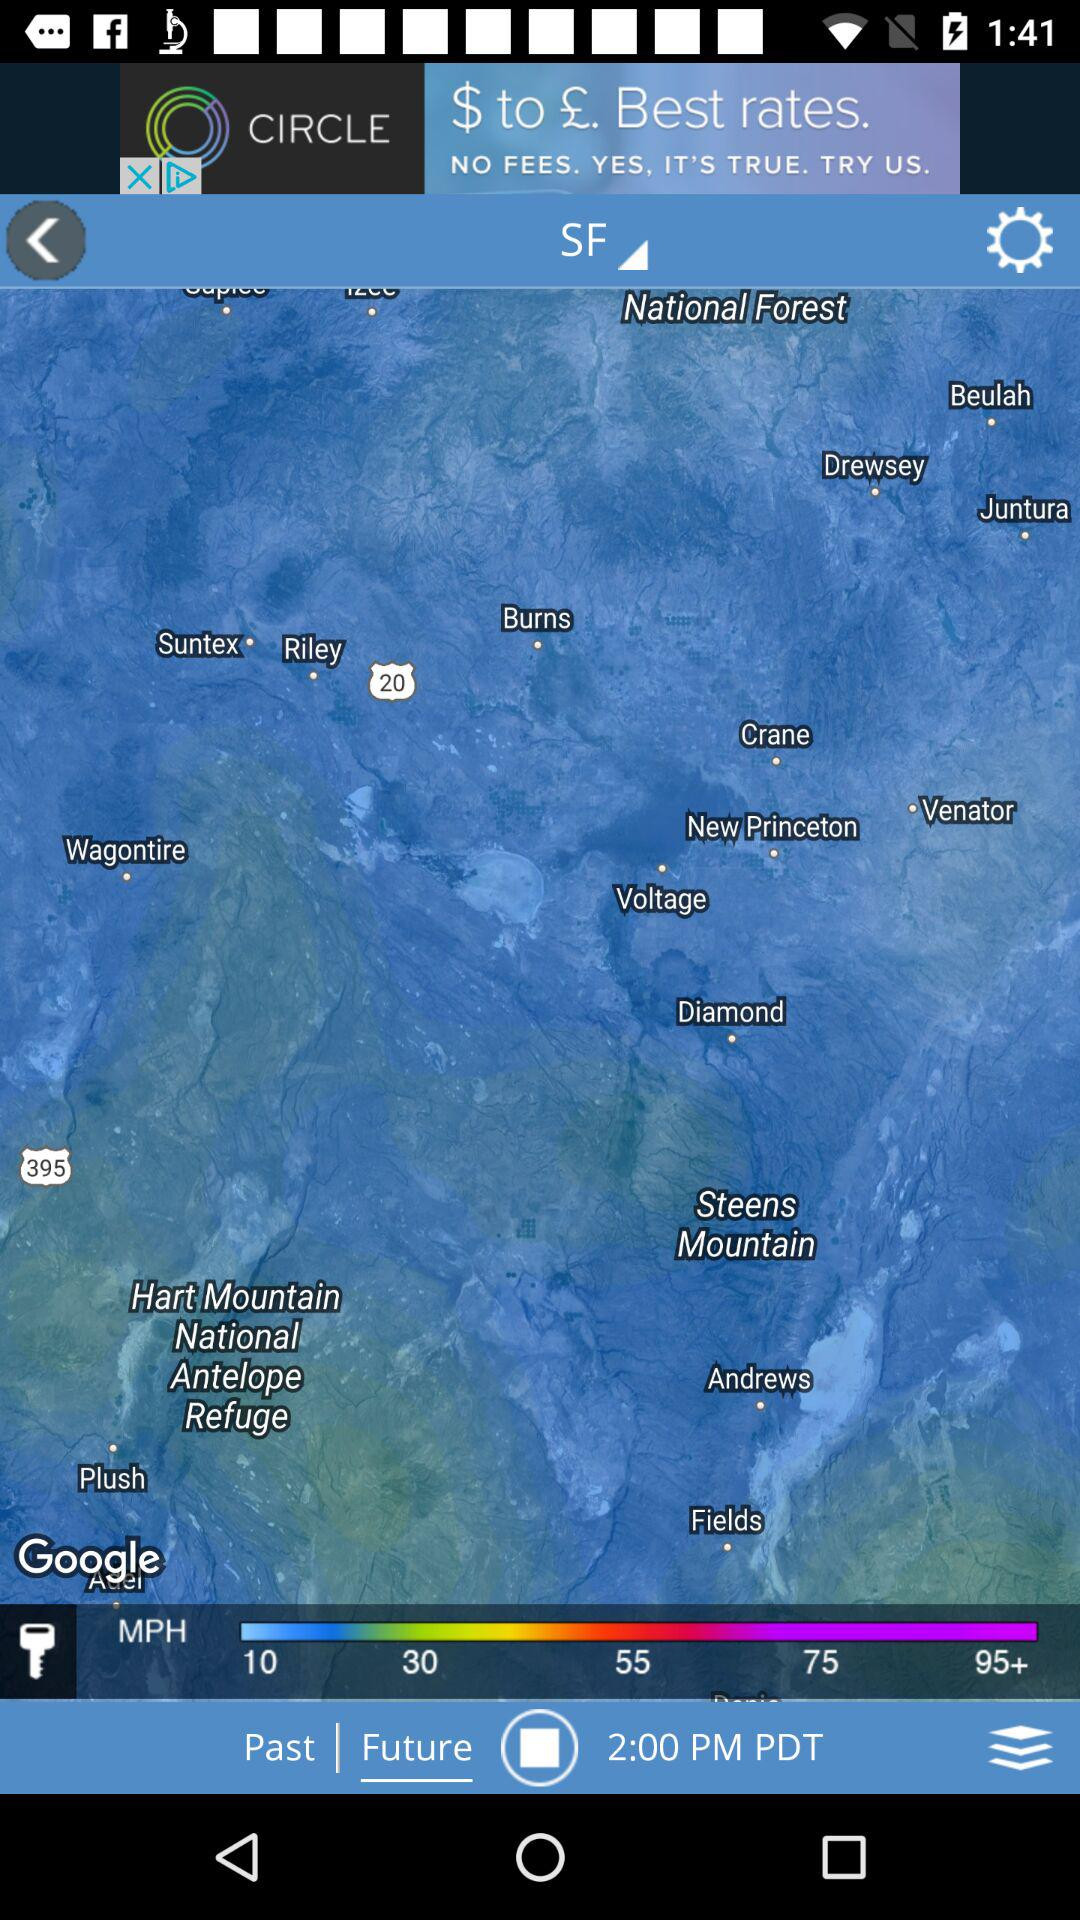How many speed options are available?
Answer the question using a single word or phrase. 5 